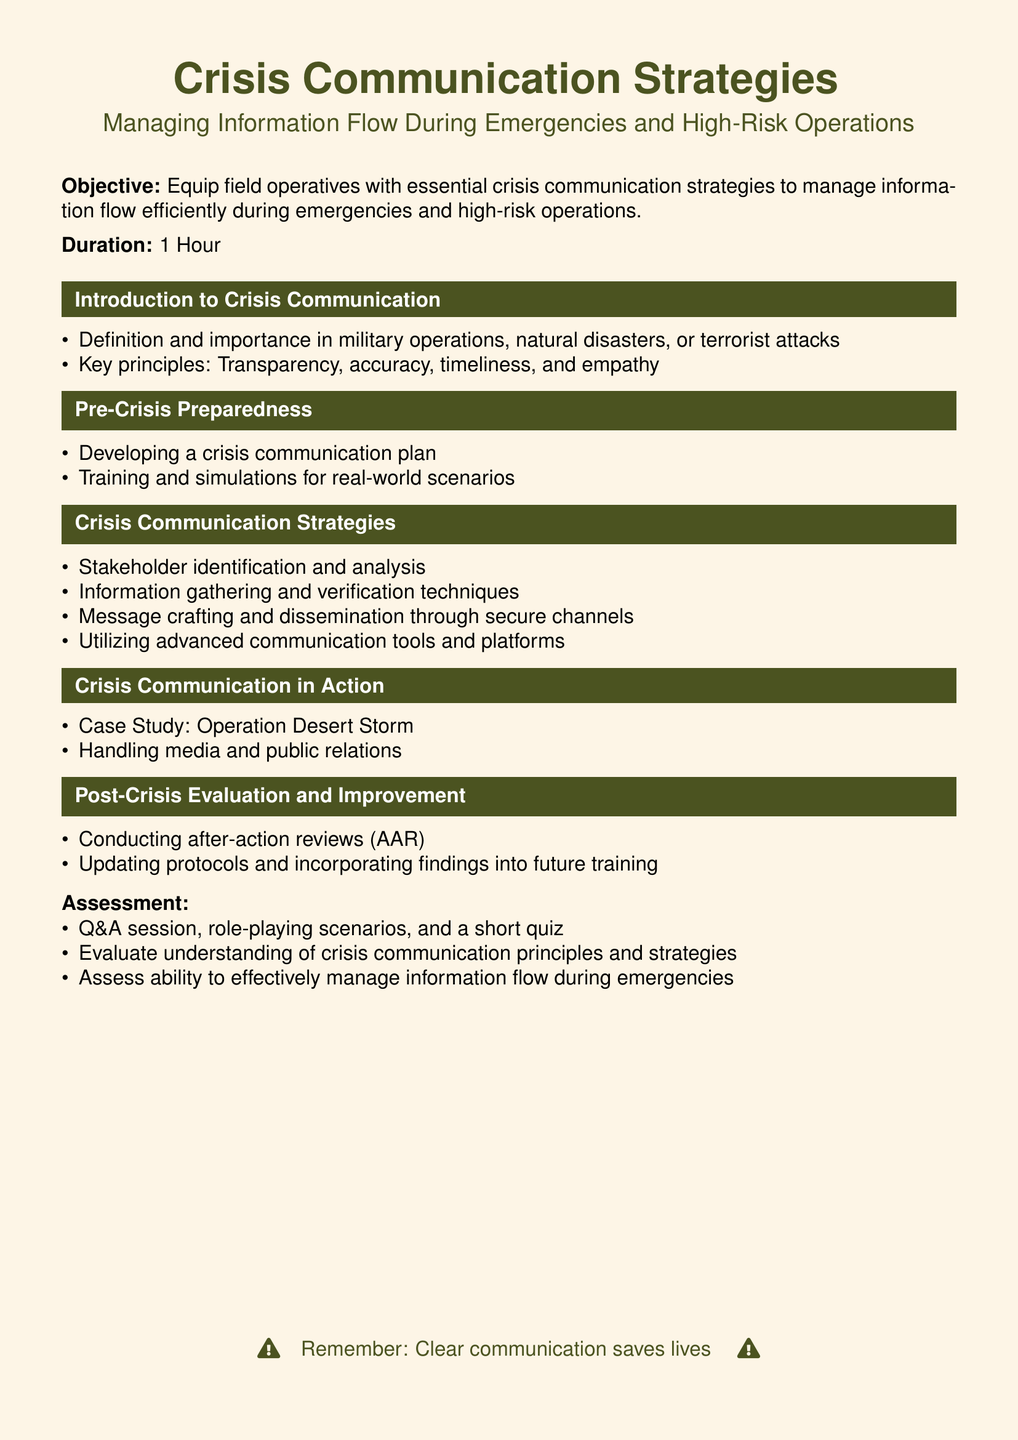What is the duration of the lesson? The duration of the lesson is stated explicitly in the document.
Answer: 1 Hour What is the main objective of the lesson? The main objective is described at the beginning of the document.
Answer: Equip field operatives with essential crisis communication strategies What are the key principles of crisis communication? Key principles are listed under the introduction section of the document.
Answer: Transparency, accuracy, timeliness, and empathy What is one method for post-crisis evaluation mentioned? The document lists methods for post-crisis evaluation under a specific section.
Answer: Conducting after-action reviews Which case study is included in the lesson? The lesson contains a specific case study as an example of crisis communication strategies.
Answer: Operation Desert Storm What type of assessment is mentioned? The assessment methods are detailed in the assessment section of the document.
Answer: Q&A session, role-playing scenarios, and a short quiz What is emphasized at the end of the document? The end of the document contains a reminder about the importance of communication during crises.
Answer: Clear communication saves lives 